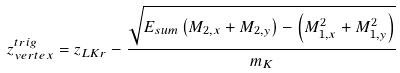<formula> <loc_0><loc_0><loc_500><loc_500>z ^ { t r i g } _ { v e r t e x } = z _ { L K r } - \frac { \sqrt { E _ { s u m } \left ( M _ { 2 , x } + M _ { 2 , y } \right ) - \left ( M ^ { 2 } _ { 1 , x } + M ^ { 2 } _ { 1 , y } \right ) } } { m _ { K } }</formula> 